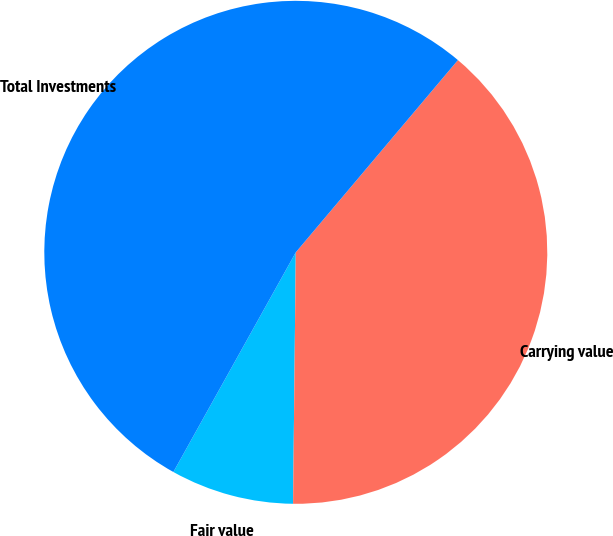<chart> <loc_0><loc_0><loc_500><loc_500><pie_chart><fcel>Fair value<fcel>Carrying value<fcel>Total Investments<nl><fcel>7.92%<fcel>39.02%<fcel>53.06%<nl></chart> 